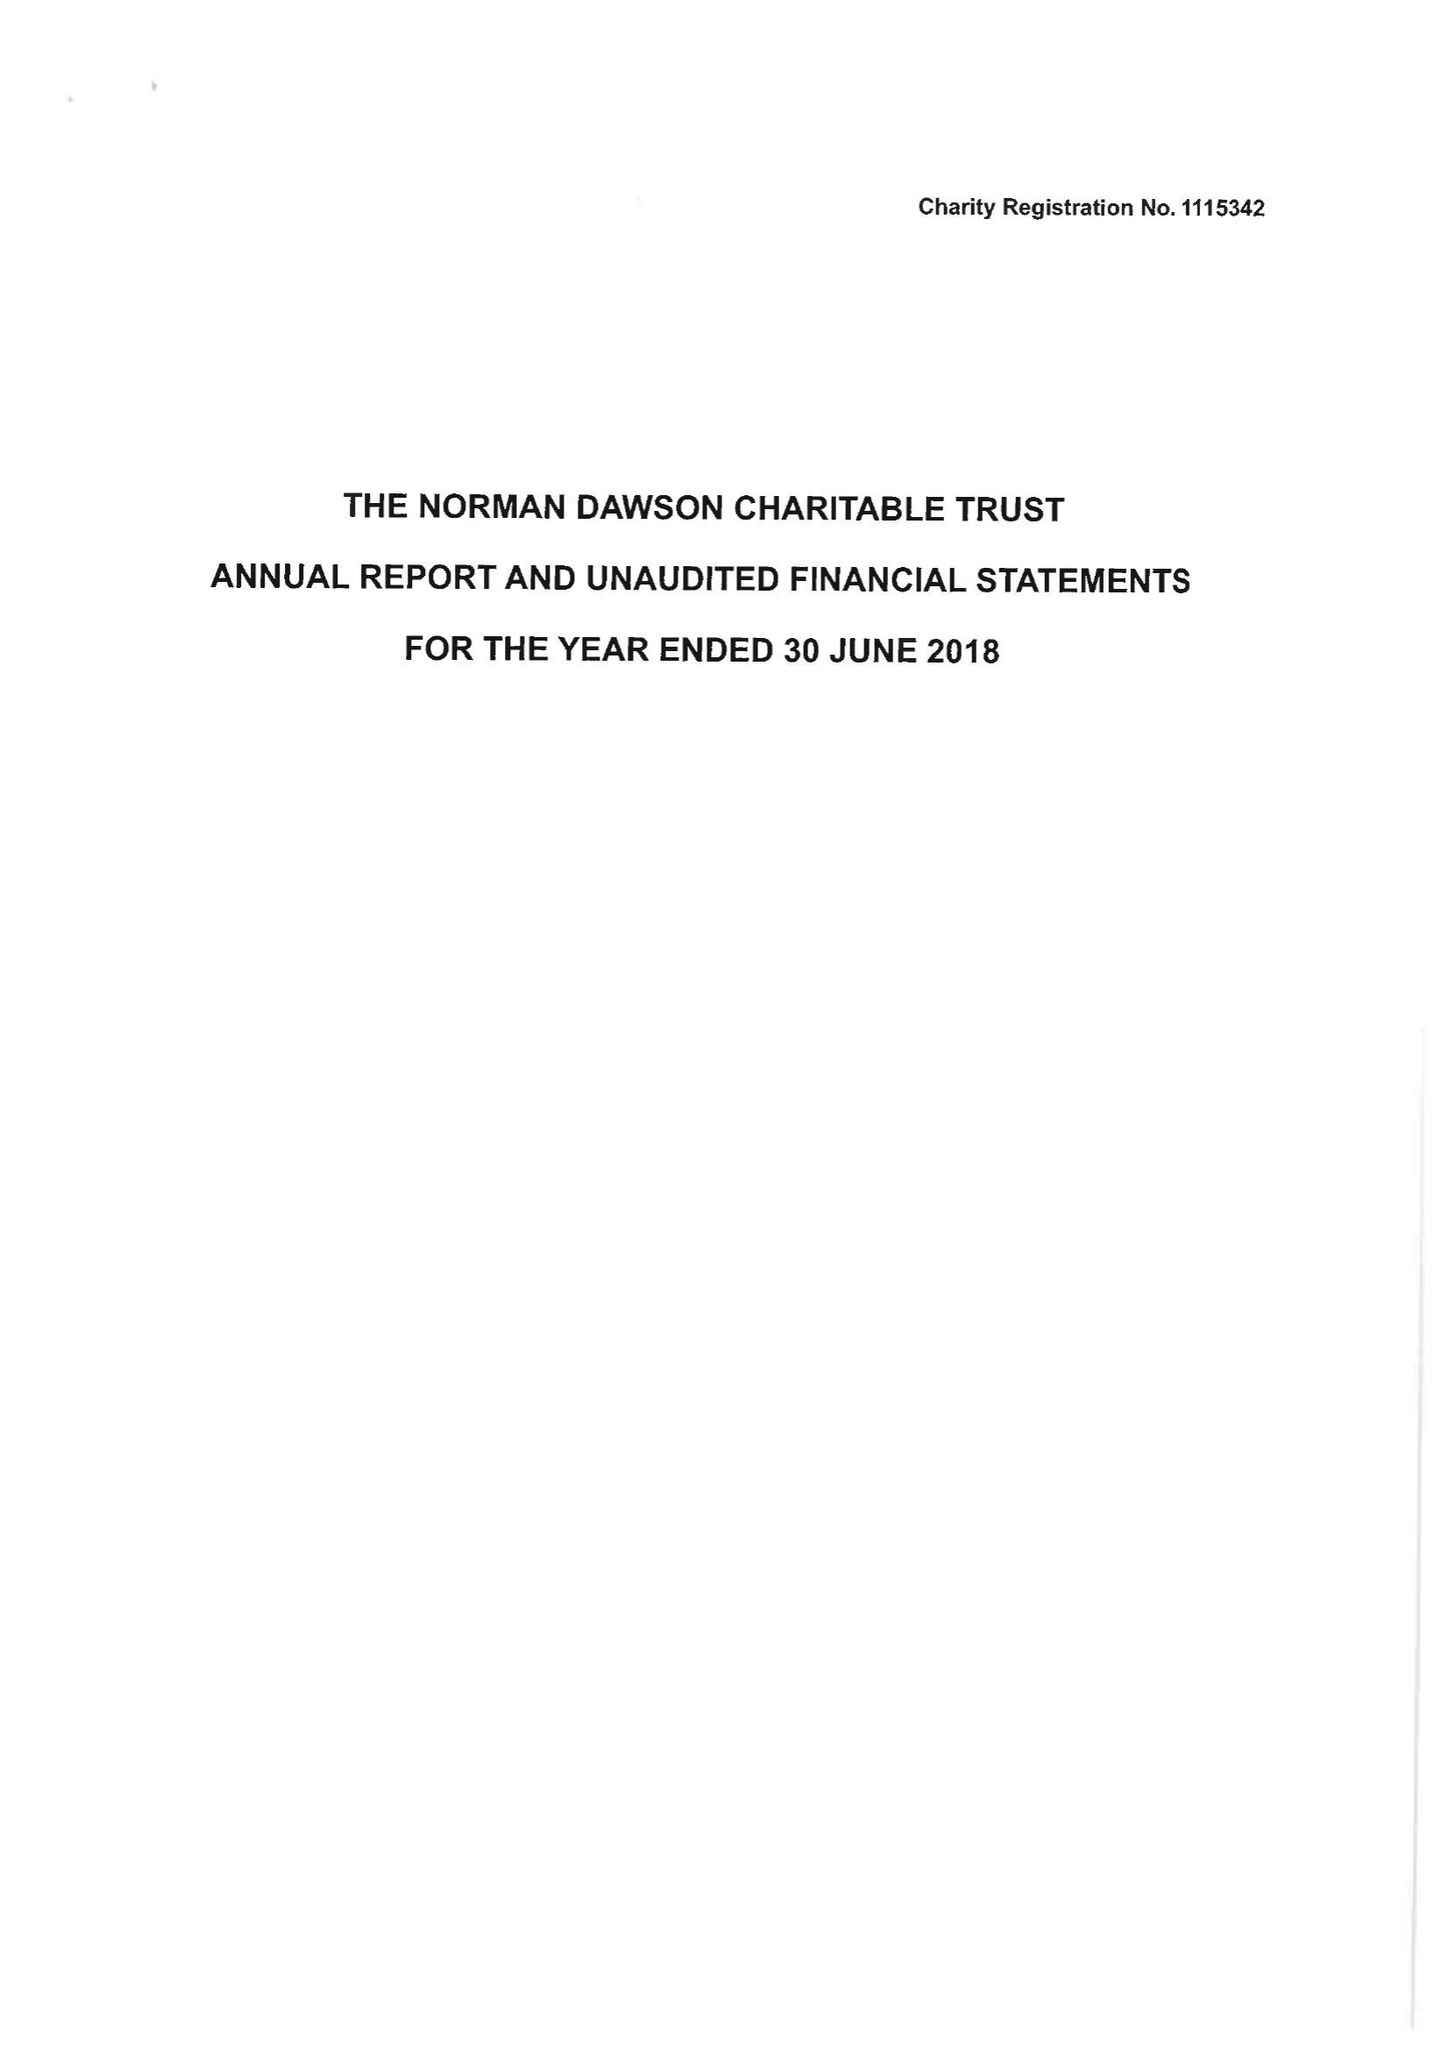What is the value for the charity_number?
Answer the question using a single word or phrase. 1115342 